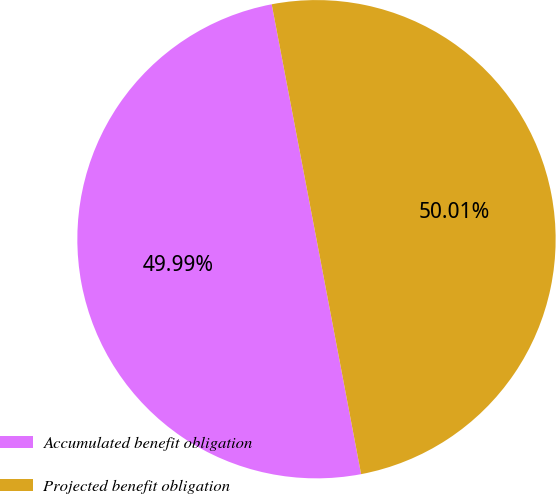Convert chart. <chart><loc_0><loc_0><loc_500><loc_500><pie_chart><fcel>Accumulated benefit obligation<fcel>Projected benefit obligation<nl><fcel>49.99%<fcel>50.01%<nl></chart> 